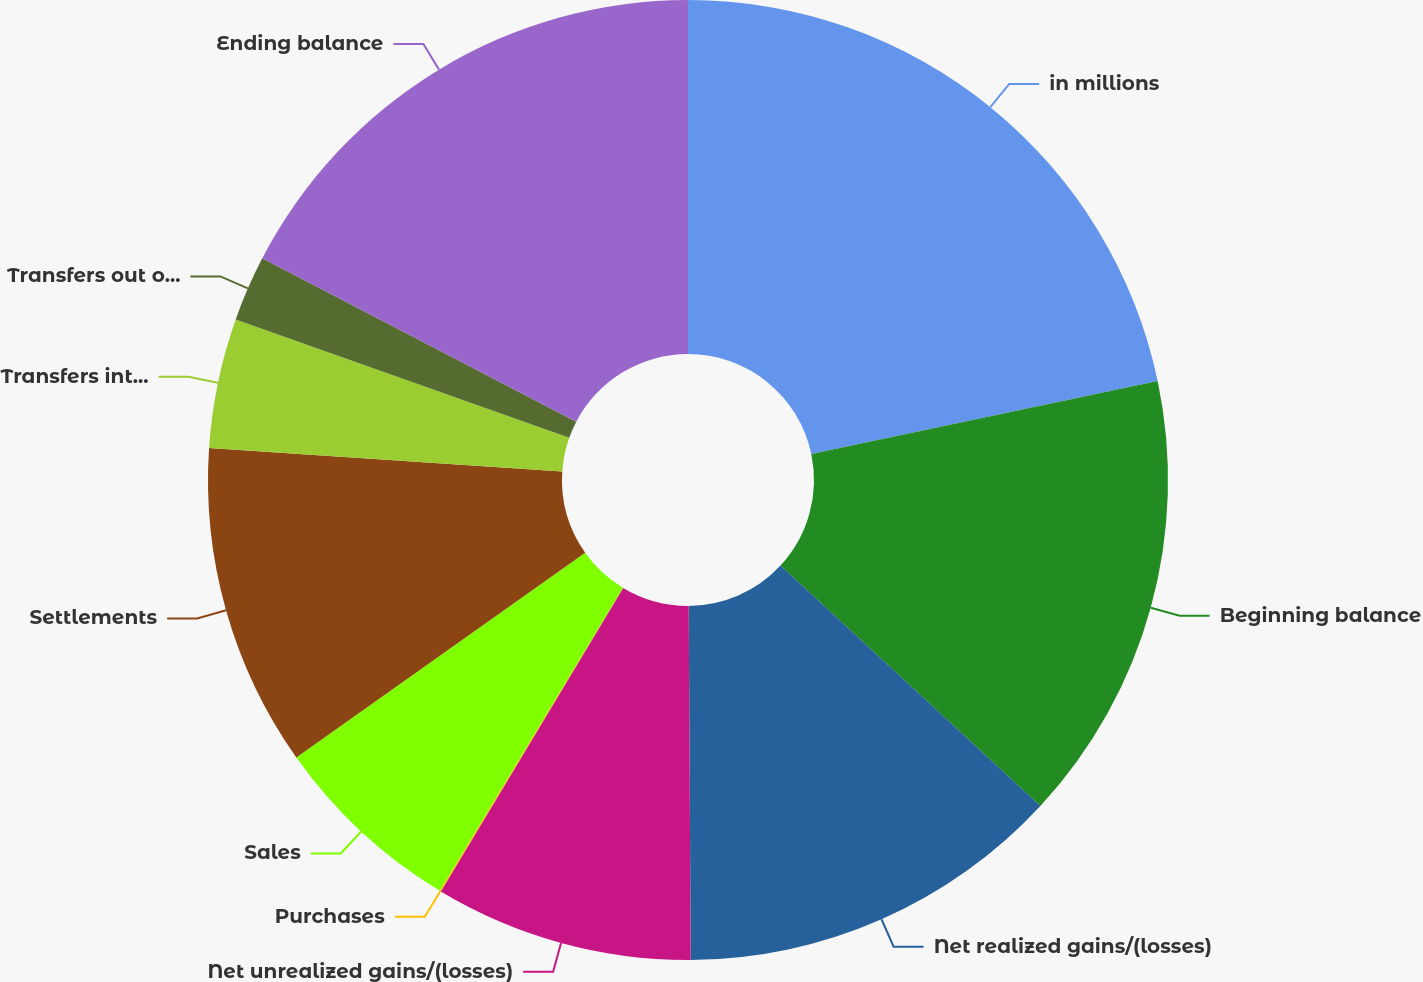Convert chart. <chart><loc_0><loc_0><loc_500><loc_500><pie_chart><fcel>in millions<fcel>Beginning balance<fcel>Net realized gains/(losses)<fcel>Net unrealized gains/(losses)<fcel>Purchases<fcel>Sales<fcel>Settlements<fcel>Transfers into level 3<fcel>Transfers out of level 3<fcel>Ending balance<nl><fcel>21.69%<fcel>15.19%<fcel>13.03%<fcel>8.7%<fcel>0.04%<fcel>6.54%<fcel>10.87%<fcel>4.37%<fcel>2.21%<fcel>17.36%<nl></chart> 